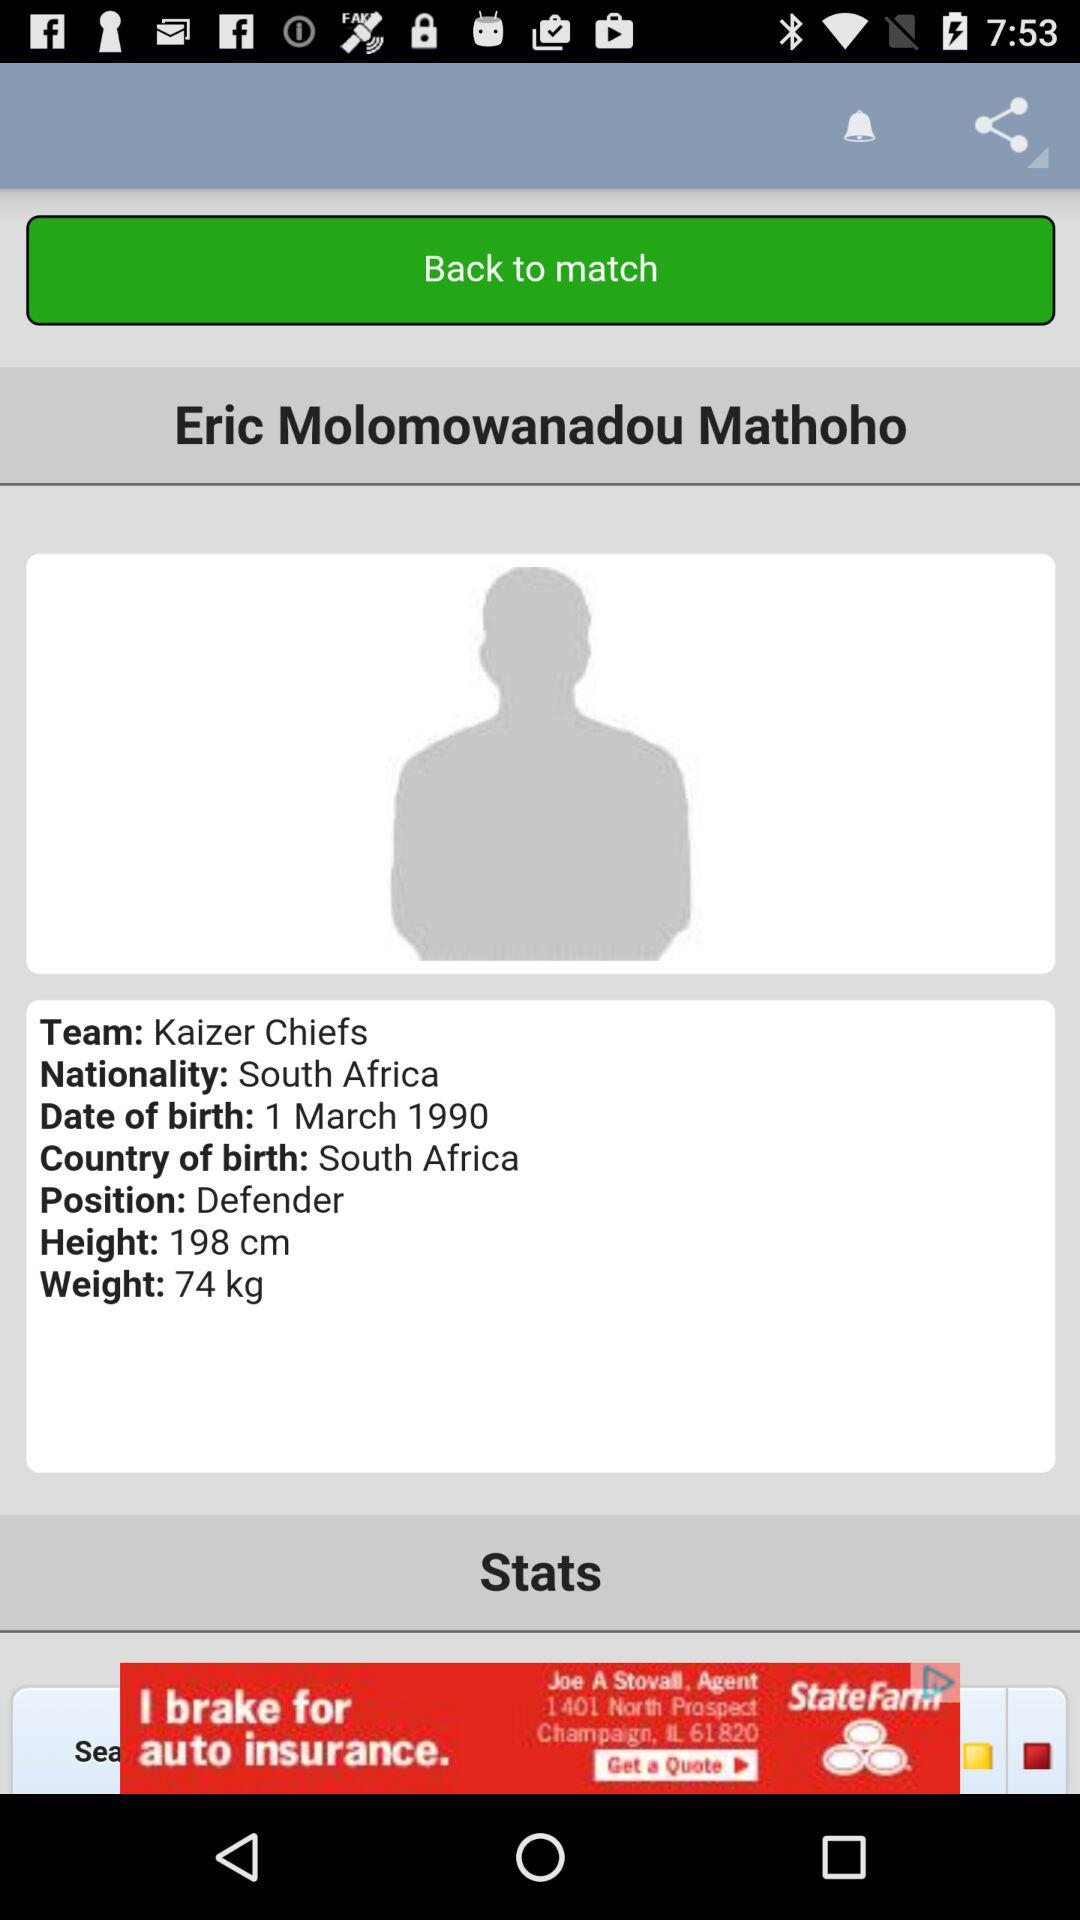How many countries does Eric Molomowanadou Mathoho have citizenship in?
Answer the question using a single word or phrase. 1 